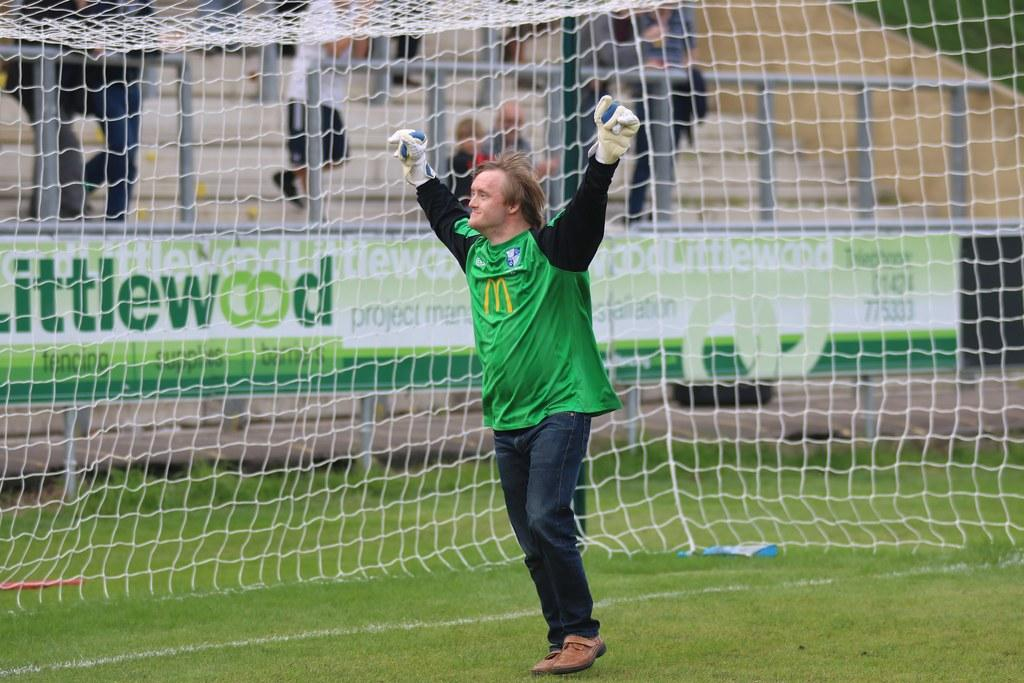<image>
Present a compact description of the photo's key features. A man stands celebrating in a goal in front of an advert for Littlewood. 